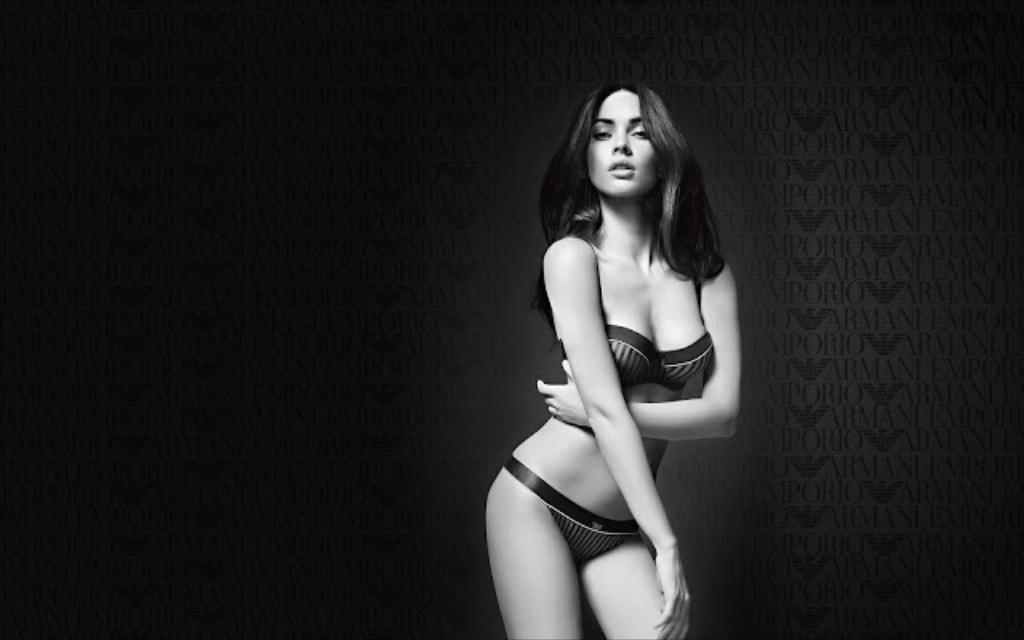Who is present in the image? There is a woman in the image. What is the woman doing in the image? The woman is standing. What time does the clock show in the image? There is no clock present in the image. What type of competition is the woman participating in? There is no competition depicted in the image. 